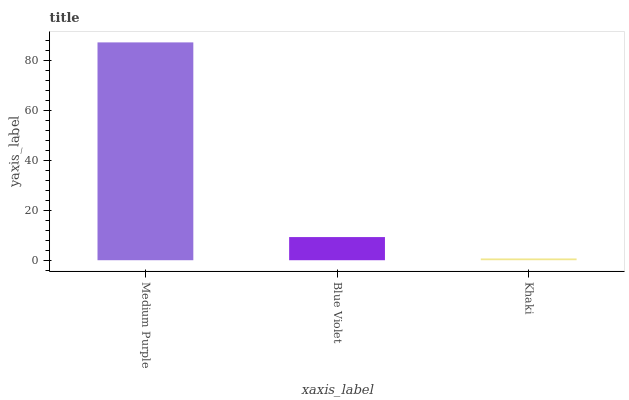Is Khaki the minimum?
Answer yes or no. Yes. Is Medium Purple the maximum?
Answer yes or no. Yes. Is Blue Violet the minimum?
Answer yes or no. No. Is Blue Violet the maximum?
Answer yes or no. No. Is Medium Purple greater than Blue Violet?
Answer yes or no. Yes. Is Blue Violet less than Medium Purple?
Answer yes or no. Yes. Is Blue Violet greater than Medium Purple?
Answer yes or no. No. Is Medium Purple less than Blue Violet?
Answer yes or no. No. Is Blue Violet the high median?
Answer yes or no. Yes. Is Blue Violet the low median?
Answer yes or no. Yes. Is Medium Purple the high median?
Answer yes or no. No. Is Khaki the low median?
Answer yes or no. No. 